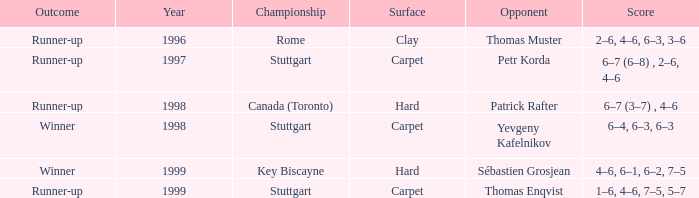What occurred as a consequence before 1997? Runner-up. 